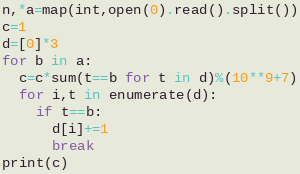Convert code to text. <code><loc_0><loc_0><loc_500><loc_500><_Python_>n,*a=map(int,open(0).read().split())
c=1
d=[0]*3
for b in a:
  c=c*sum(t==b for t in d)%(10**9+7)
  for i,t in enumerate(d):
    if t==b:
      d[i]+=1
      break
print(c)</code> 